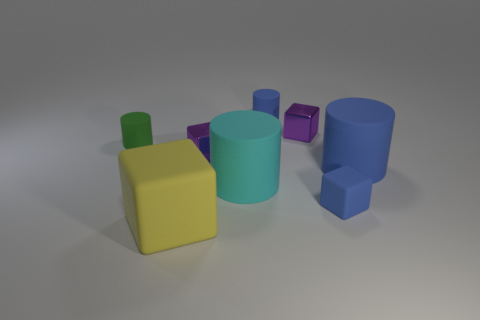How is the lighting in the image? Does it create any interesting effects? The lighting in the image is soft and diffused, coming from the upper left side, which creates gentle shadows on the right sides of the objects. These shadows add depth to the scene without creating any harsh contrasts. 